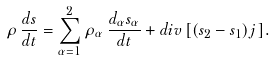<formula> <loc_0><loc_0><loc_500><loc_500>\rho \, \frac { d s } { d t } = \sum _ { \alpha = 1 } ^ { 2 } \rho _ { \alpha } \, \frac { d _ { \alpha } s _ { \alpha } } { d t } + d i v \, [ ( s _ { 2 } - s _ { 1 } ) j \, ] .</formula> 